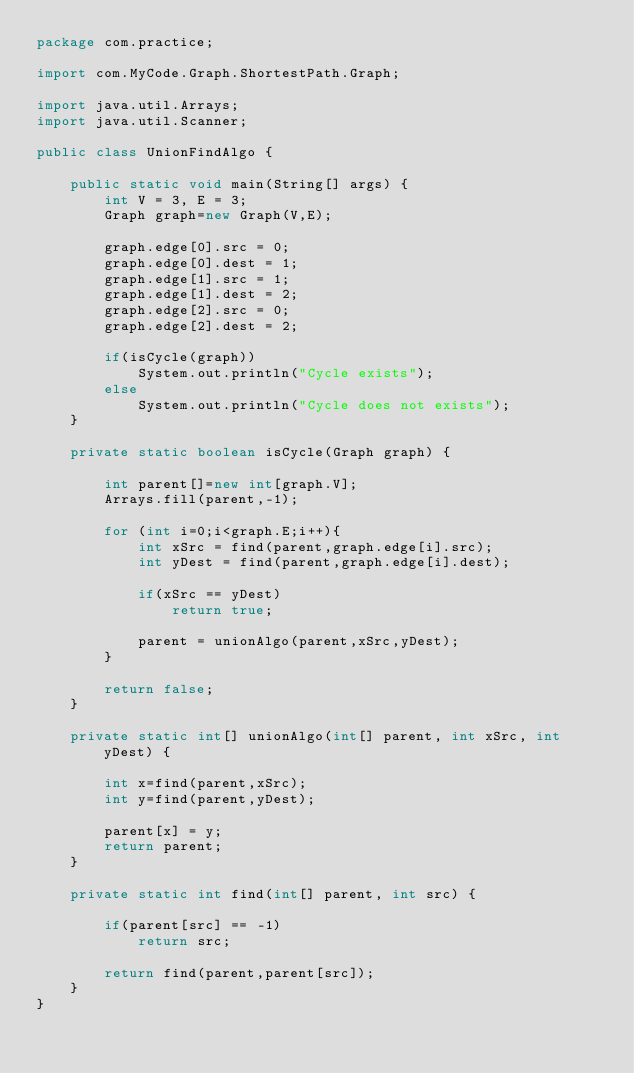<code> <loc_0><loc_0><loc_500><loc_500><_Java_>package com.practice;

import com.MyCode.Graph.ShortestPath.Graph;

import java.util.Arrays;
import java.util.Scanner;

public class UnionFindAlgo {

    public static void main(String[] args) {
        int V = 3, E = 3;
        Graph graph=new Graph(V,E);

        graph.edge[0].src = 0;
        graph.edge[0].dest = 1;
        graph.edge[1].src = 1;
        graph.edge[1].dest = 2;
        graph.edge[2].src = 0;
        graph.edge[2].dest = 2;

        if(isCycle(graph))
            System.out.println("Cycle exists");
        else
            System.out.println("Cycle does not exists");
    }

    private static boolean isCycle(Graph graph) {

        int parent[]=new int[graph.V];
        Arrays.fill(parent,-1);

        for (int i=0;i<graph.E;i++){
            int xSrc = find(parent,graph.edge[i].src);
            int yDest = find(parent,graph.edge[i].dest);

            if(xSrc == yDest)
                return true;

            parent = unionAlgo(parent,xSrc,yDest);
        }

        return false;
    }

    private static int[] unionAlgo(int[] parent, int xSrc, int yDest) {

        int x=find(parent,xSrc);
        int y=find(parent,yDest);

        parent[x] = y;
        return parent;
    }

    private static int find(int[] parent, int src) {

        if(parent[src] == -1)
            return src;

        return find(parent,parent[src]);
    }
}
</code> 